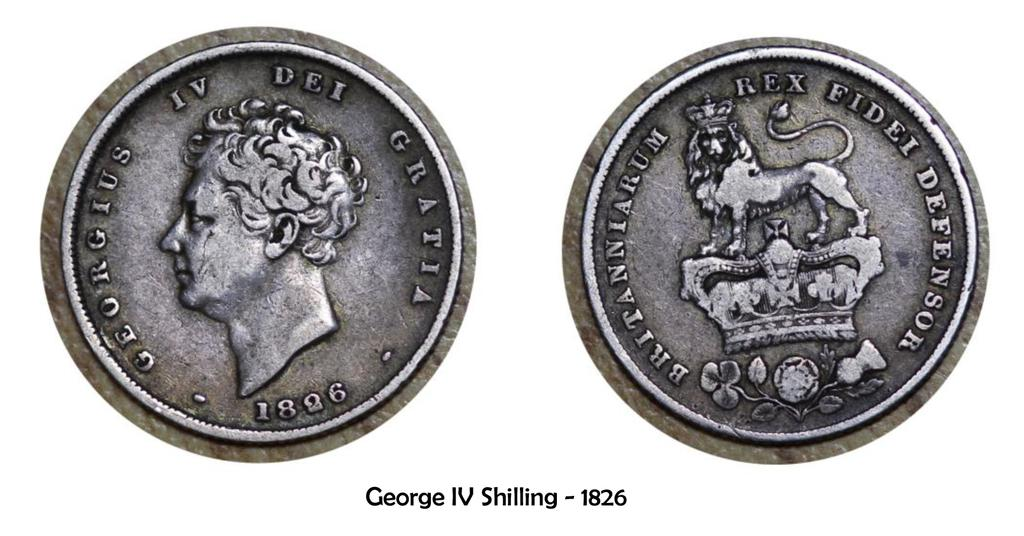<image>
Share a concise interpretation of the image provided. The old silver coin shown was made in 1826. 